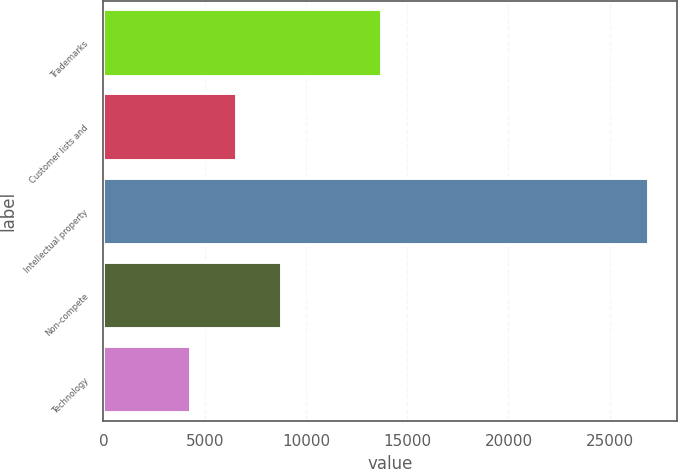Convert chart to OTSL. <chart><loc_0><loc_0><loc_500><loc_500><bar_chart><fcel>Trademarks<fcel>Customer lists and<fcel>Intellectual property<fcel>Non-compete<fcel>Technology<nl><fcel>13777<fcel>6572.8<fcel>26956<fcel>8837.6<fcel>4308<nl></chart> 